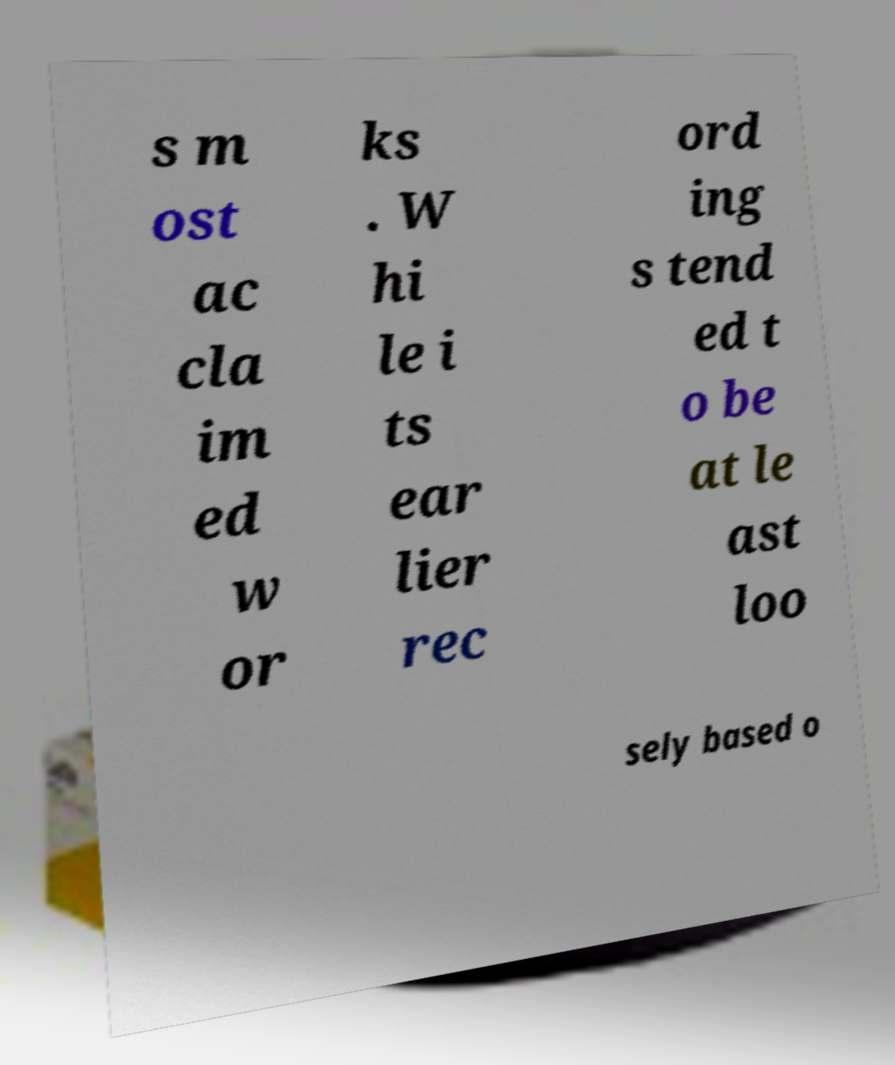Can you accurately transcribe the text from the provided image for me? s m ost ac cla im ed w or ks . W hi le i ts ear lier rec ord ing s tend ed t o be at le ast loo sely based o 